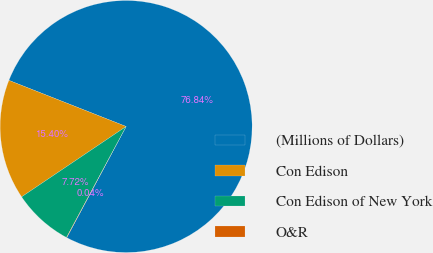<chart> <loc_0><loc_0><loc_500><loc_500><pie_chart><fcel>(Millions of Dollars)<fcel>Con Edison<fcel>Con Edison of New York<fcel>O&R<nl><fcel>76.84%<fcel>15.4%<fcel>7.72%<fcel>0.04%<nl></chart> 